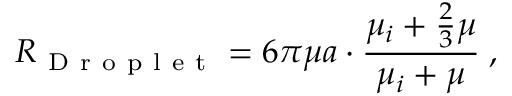Convert formula to latex. <formula><loc_0><loc_0><loc_500><loc_500>R _ { D r o p l e t } = 6 \pi \mu a \cdot \frac { \mu _ { i } + \frac { 2 } { 3 } \mu } { \mu _ { i } + \mu } \, ,</formula> 